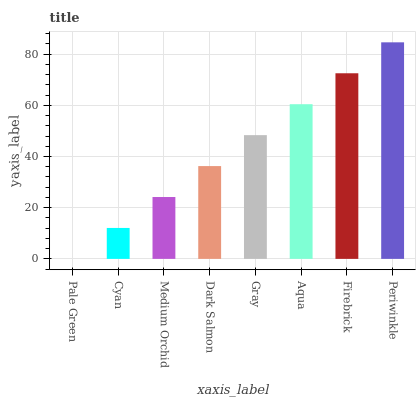Is Pale Green the minimum?
Answer yes or no. Yes. Is Periwinkle the maximum?
Answer yes or no. Yes. Is Cyan the minimum?
Answer yes or no. No. Is Cyan the maximum?
Answer yes or no. No. Is Cyan greater than Pale Green?
Answer yes or no. Yes. Is Pale Green less than Cyan?
Answer yes or no. Yes. Is Pale Green greater than Cyan?
Answer yes or no. No. Is Cyan less than Pale Green?
Answer yes or no. No. Is Gray the high median?
Answer yes or no. Yes. Is Dark Salmon the low median?
Answer yes or no. Yes. Is Medium Orchid the high median?
Answer yes or no. No. Is Pale Green the low median?
Answer yes or no. No. 